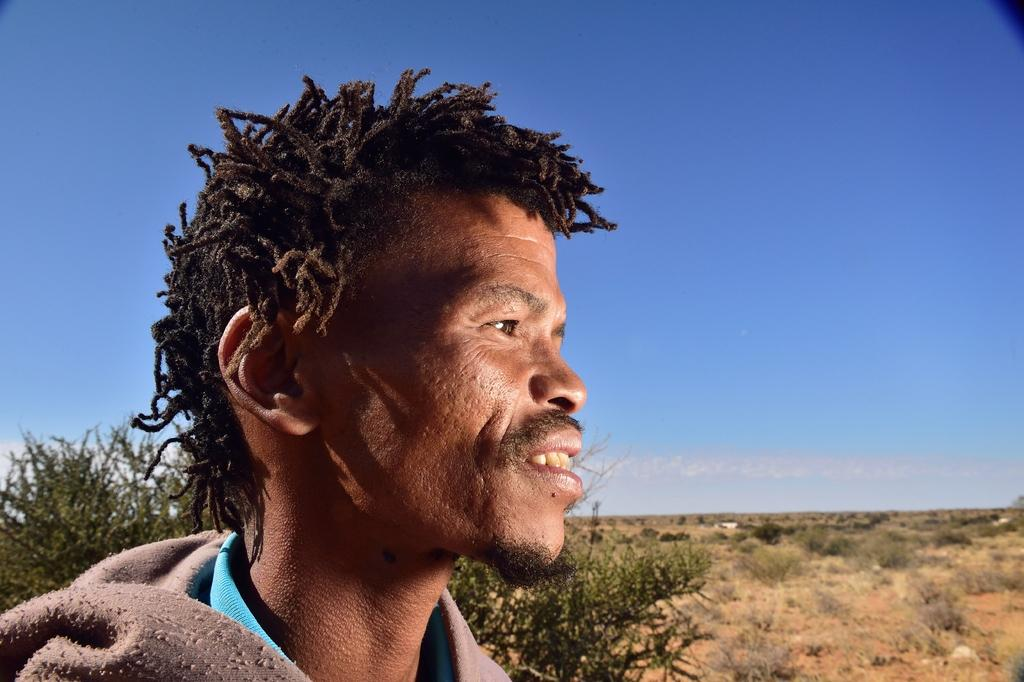What is the main subject of the image? There is a person standing in the image. What can be seen in the background of the image? There are trees and plants in the backdrop of the image. How would you describe the weather in the image? The sky is clear in the image, suggesting good weather. What type of comb is the person using in the image? There is no comb visible in the image. What is the name of the person in the image? The name of the person in the image is not mentioned or visible. 